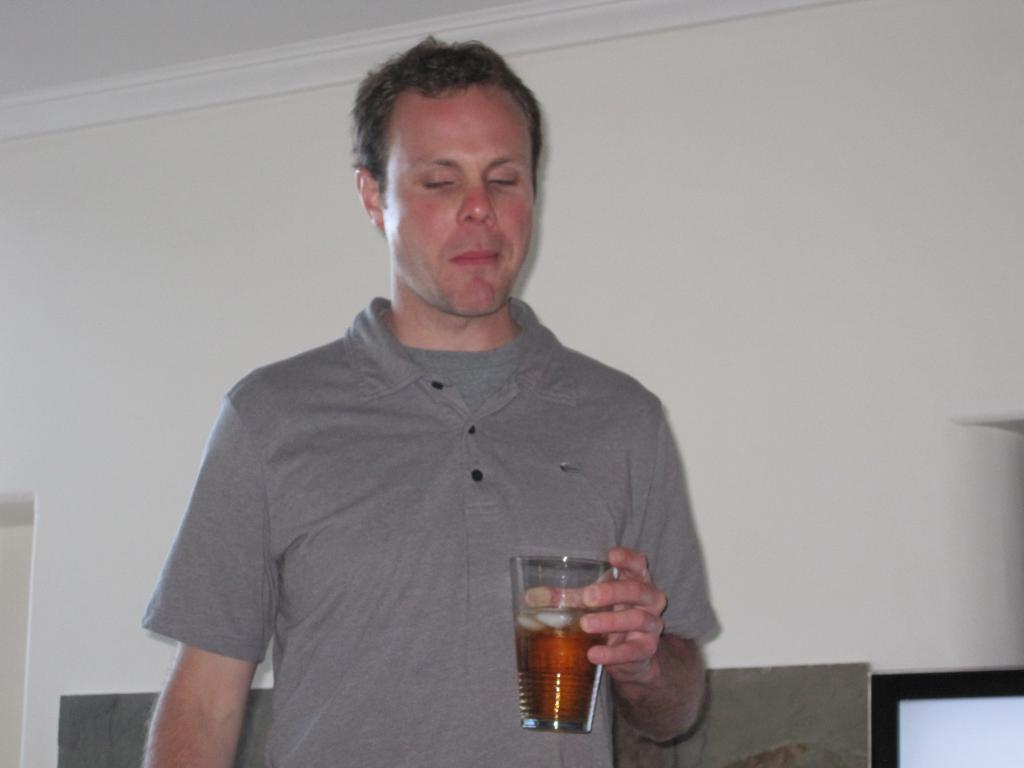What is the man in the image doing? The man is standing in the image. What is the man holding in his hand? The man is holding a glass in his hand. What type of clothing is the man wearing? The man is wearing a t-shirt. What can be seen in the background of the image? There is a wall in the background of the image. What page of the rulebook is the man referring to in the image? There is no rulebook or reference to a page in the image; it only shows a man standing and holding a glass. What type of machine is the man operating in the image? There is no machine present in the image; it only shows a man standing and holding a glass. 